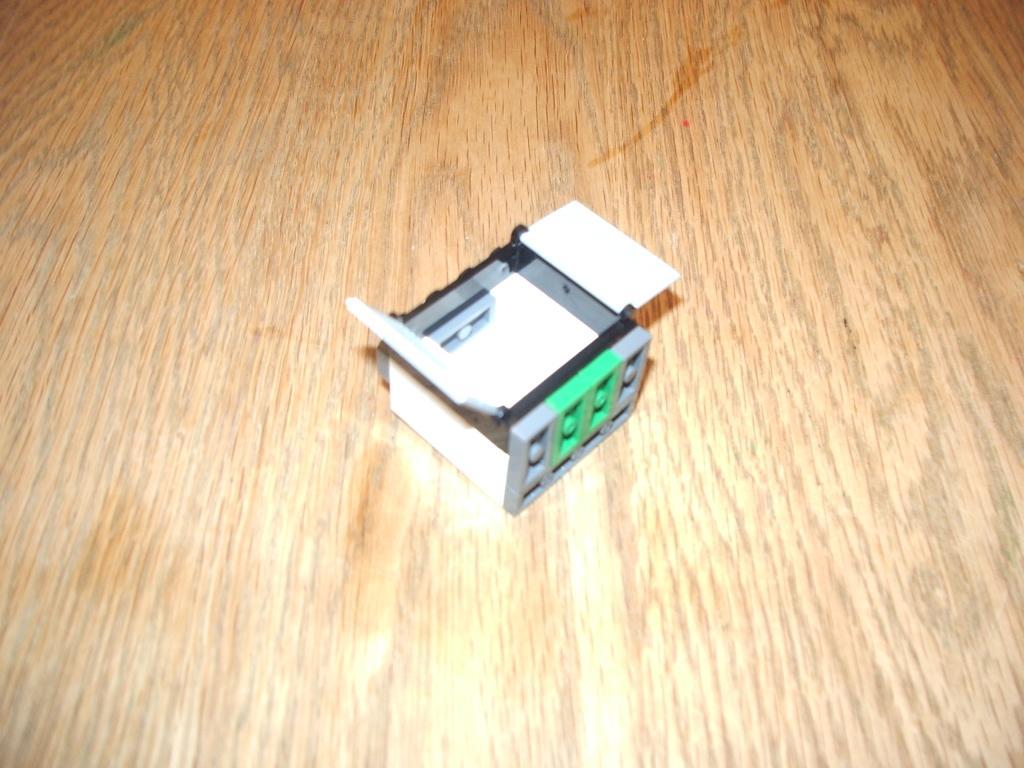How would you summarize this image in a sentence or two? In this image we can see a block placed on the wooden surface. 